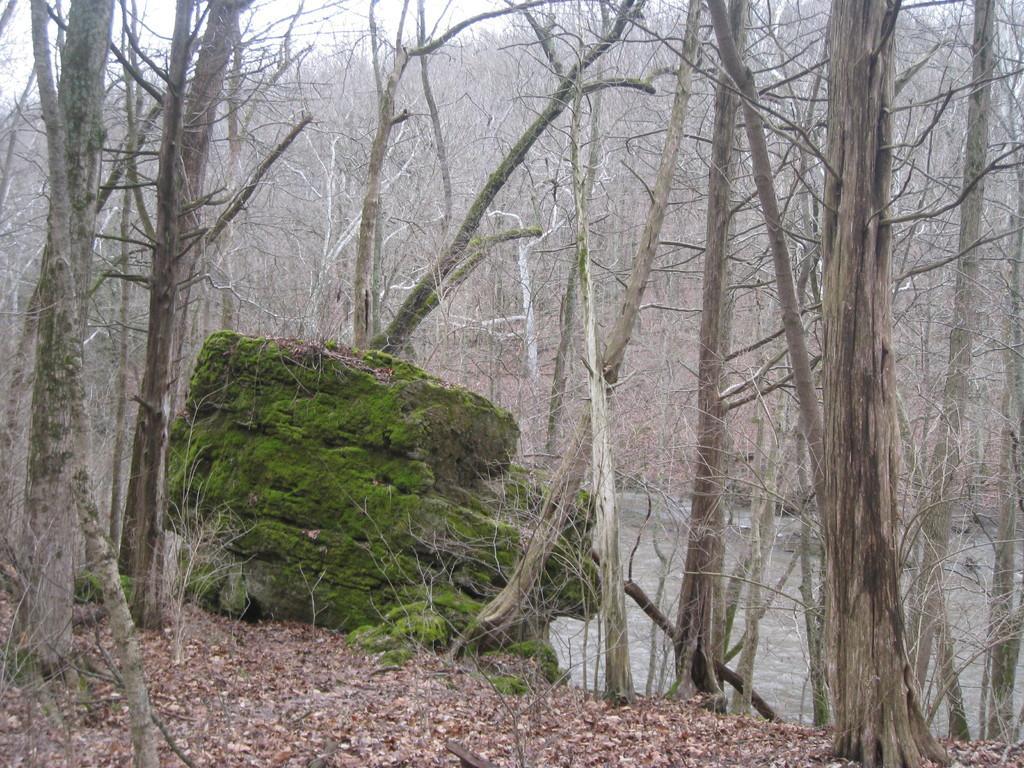Can you describe this image briefly? In this image there are trees. In the background there is sky. At the bottom there is water and we can see leaves. 